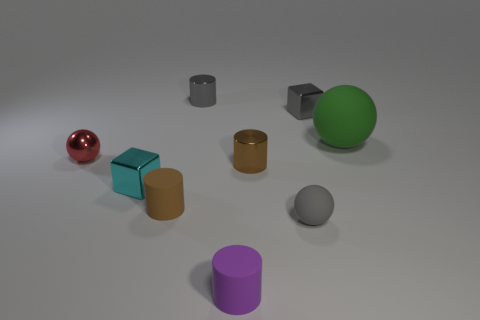Can you describe the lighting in the scene? The lighting in the scene seems to be diffuse, with soft shadows indicating an overhead light source, perhaps simulating an overcast sky or softbox lighting commonly used in photography studios. Does the lighting affect the appearance of the materials? Absolutely. The lighting impacts how materials are perceived. For instance, the soft lighting helps enhance the differences between matte and shiny surfaces, making the reflective qualities of the metallic objects more noticeable and softening the appearance of the more absorbent, matte materials. 